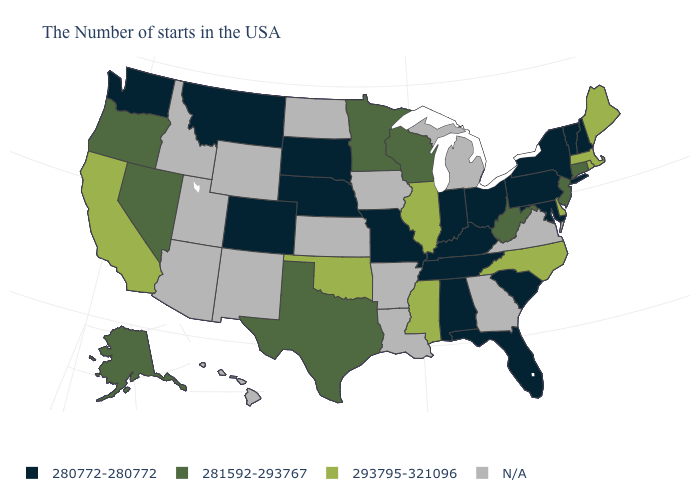What is the highest value in the USA?
Write a very short answer. 293795-321096. Which states have the lowest value in the USA?
Concise answer only. New Hampshire, Vermont, New York, Maryland, Pennsylvania, South Carolina, Ohio, Florida, Kentucky, Indiana, Alabama, Tennessee, Missouri, Nebraska, South Dakota, Colorado, Montana, Washington. Name the states that have a value in the range 280772-280772?
Answer briefly. New Hampshire, Vermont, New York, Maryland, Pennsylvania, South Carolina, Ohio, Florida, Kentucky, Indiana, Alabama, Tennessee, Missouri, Nebraska, South Dakota, Colorado, Montana, Washington. Name the states that have a value in the range 280772-280772?
Write a very short answer. New Hampshire, Vermont, New York, Maryland, Pennsylvania, South Carolina, Ohio, Florida, Kentucky, Indiana, Alabama, Tennessee, Missouri, Nebraska, South Dakota, Colorado, Montana, Washington. What is the lowest value in the USA?
Write a very short answer. 280772-280772. Name the states that have a value in the range 280772-280772?
Give a very brief answer. New Hampshire, Vermont, New York, Maryland, Pennsylvania, South Carolina, Ohio, Florida, Kentucky, Indiana, Alabama, Tennessee, Missouri, Nebraska, South Dakota, Colorado, Montana, Washington. Name the states that have a value in the range N/A?
Quick response, please. Virginia, Georgia, Michigan, Louisiana, Arkansas, Iowa, Kansas, North Dakota, Wyoming, New Mexico, Utah, Arizona, Idaho, Hawaii. Is the legend a continuous bar?
Concise answer only. No. Is the legend a continuous bar?
Write a very short answer. No. Among the states that border Missouri , does Tennessee have the highest value?
Answer briefly. No. Does the first symbol in the legend represent the smallest category?
Write a very short answer. Yes. Which states have the lowest value in the USA?
Write a very short answer. New Hampshire, Vermont, New York, Maryland, Pennsylvania, South Carolina, Ohio, Florida, Kentucky, Indiana, Alabama, Tennessee, Missouri, Nebraska, South Dakota, Colorado, Montana, Washington. Name the states that have a value in the range 280772-280772?
Quick response, please. New Hampshire, Vermont, New York, Maryland, Pennsylvania, South Carolina, Ohio, Florida, Kentucky, Indiana, Alabama, Tennessee, Missouri, Nebraska, South Dakota, Colorado, Montana, Washington. Which states have the lowest value in the Northeast?
Keep it brief. New Hampshire, Vermont, New York, Pennsylvania. 